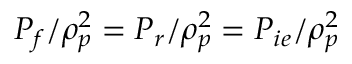Convert formula to latex. <formula><loc_0><loc_0><loc_500><loc_500>P _ { f } / \rho _ { p } ^ { 2 } = P _ { r } / \rho _ { p } ^ { 2 } = P _ { i e } / \rho _ { p } ^ { 2 }</formula> 